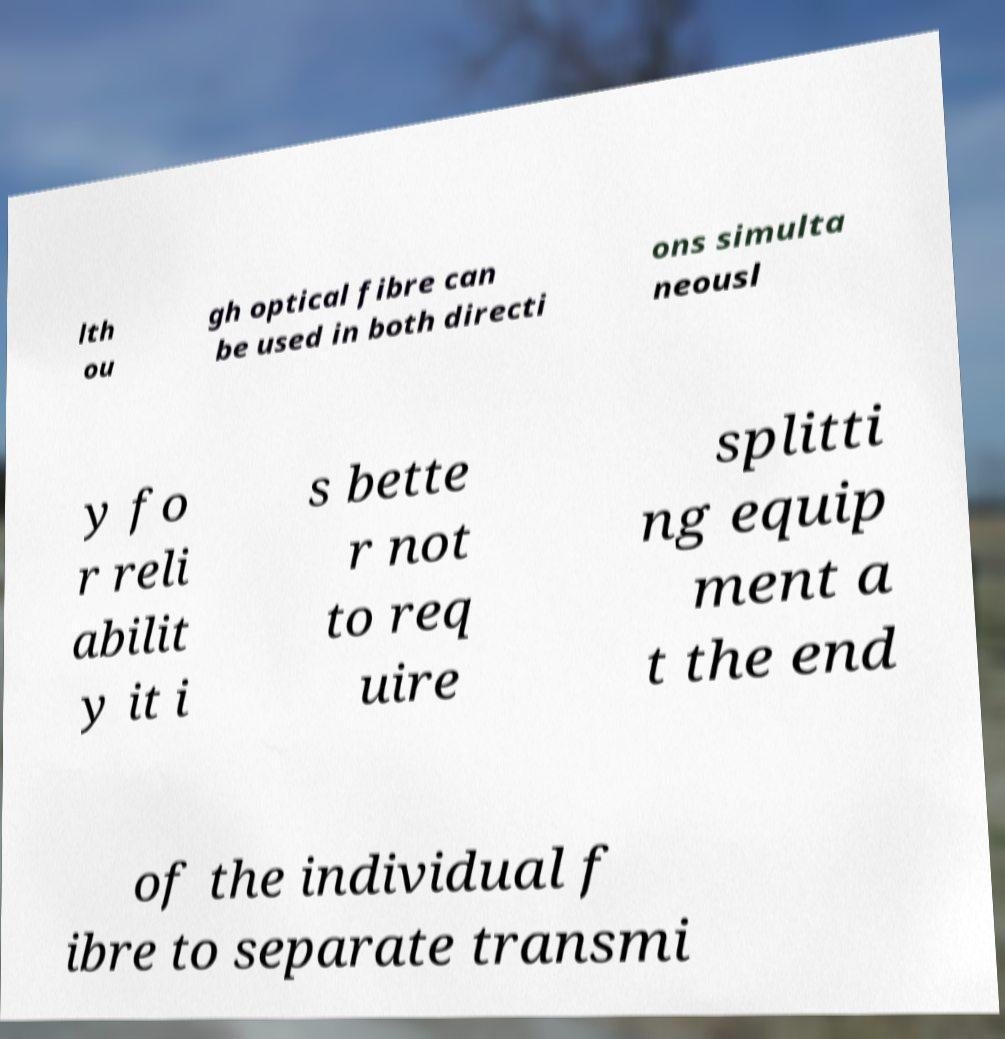Could you assist in decoding the text presented in this image and type it out clearly? lth ou gh optical fibre can be used in both directi ons simulta neousl y fo r reli abilit y it i s bette r not to req uire splitti ng equip ment a t the end of the individual f ibre to separate transmi 